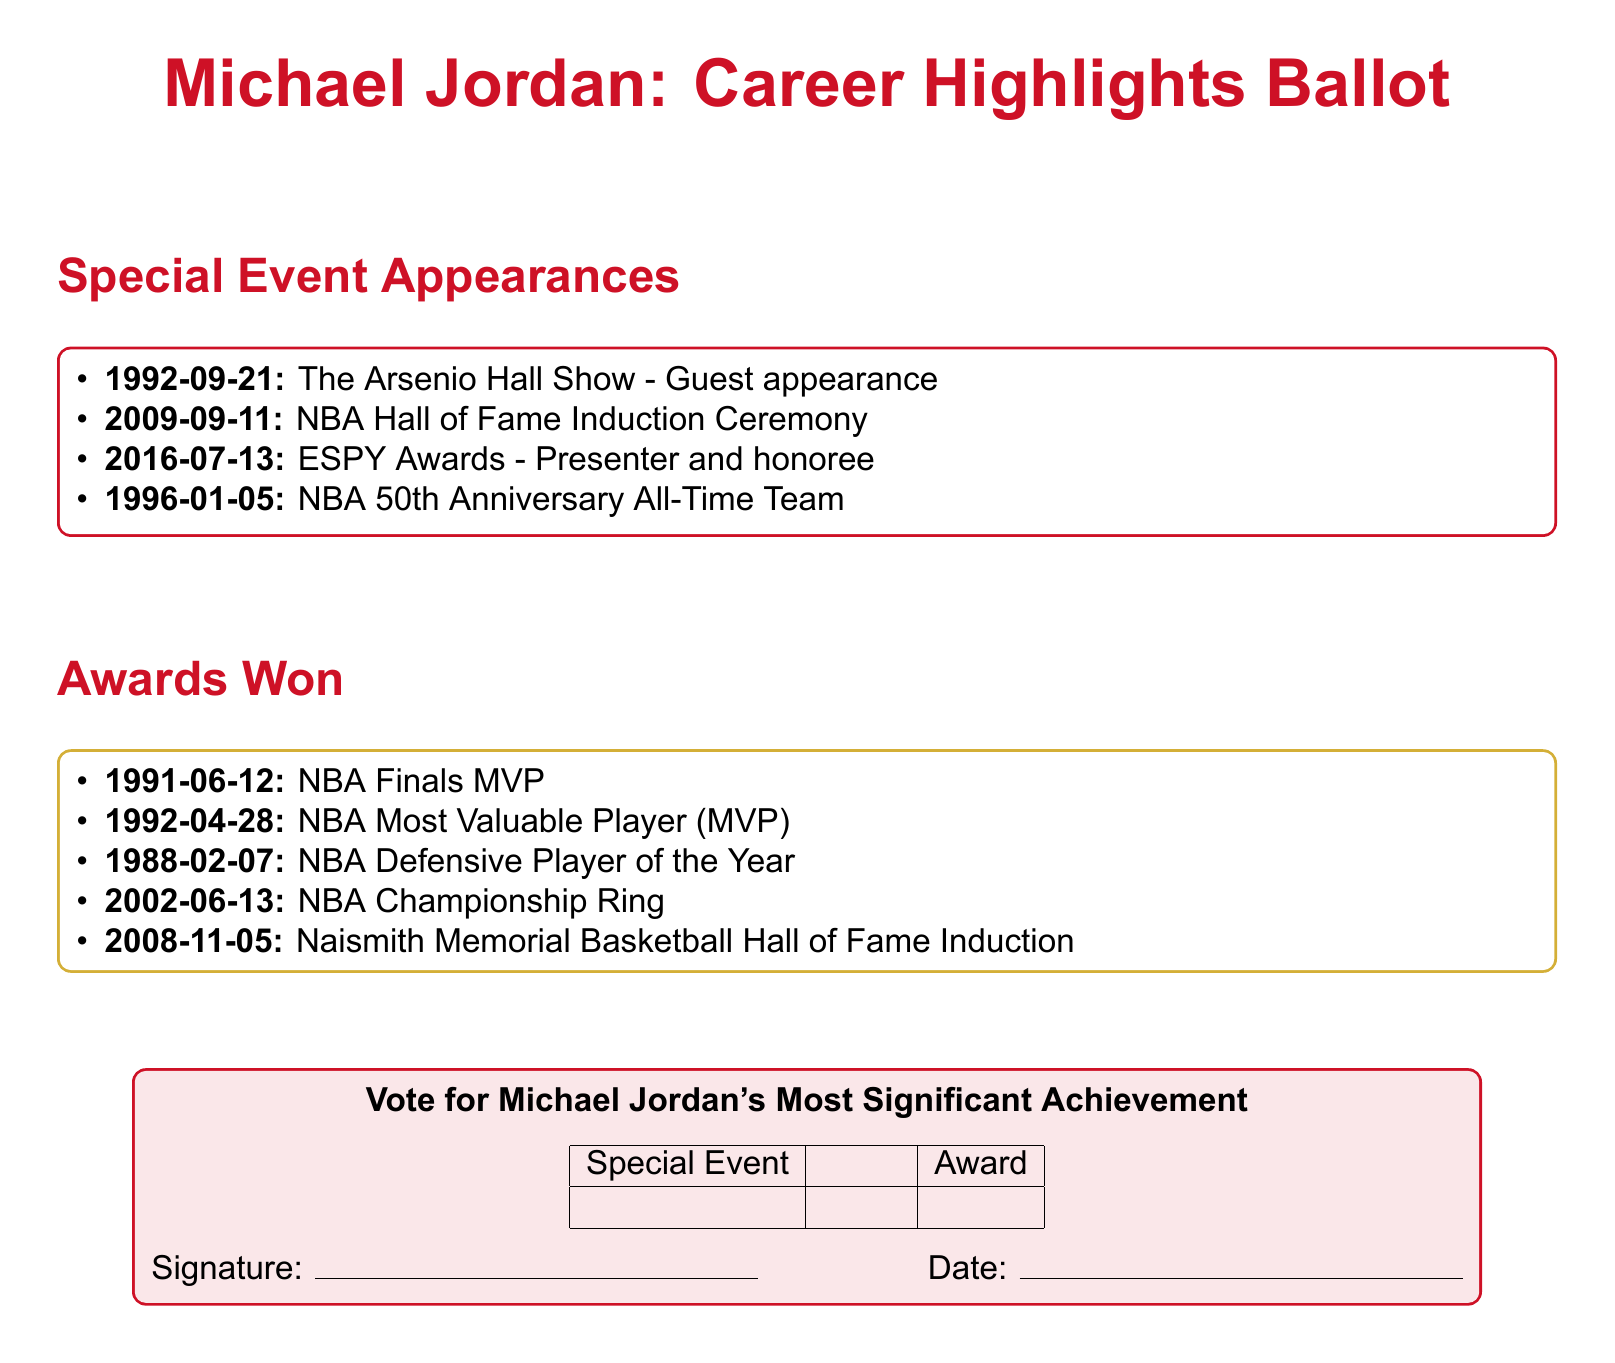What was the date of Michael Jordan's NBA Hall of Fame Induction? The NBA Hall of Fame Induction Ceremony took place on September 11, 2009.
Answer: 2009-09-11 Which event did Michael Jordan participate in on January 5, 1996? On January 5, 1996, he was part of the NBA 50th Anniversary All-Time Team.
Answer: NBA 50th Anniversary All-Time Team How many awards are listed under "Awards Won"? There are five awards listed under "Awards Won."
Answer: 5 What is the title of the show where Michael Jordan made a guest appearance on September 21, 1992? The title of the show is "The Arsenio Hall Show."
Answer: The Arsenio Hall Show Which award was received by Michael Jordan on June 12, 1991? Michael Jordan received the NBA Finals MVP award on that date.
Answer: NBA Finals MVP Which two sections are present in the document? The two sections are "Special Event Appearances" and "Awards Won."
Answer: Special Event Appearances, Awards Won What is the color of the box containing the awards? The box containing the awards is colored gold accent.
Answer: goldaccent In the ballot, what action is the participant invited to do regarding Michael Jordan's achievements? The participant is invited to vote for Michael Jordan's most significant achievement.
Answer: Vote for Michael Jordan's Most Significant Achievement 